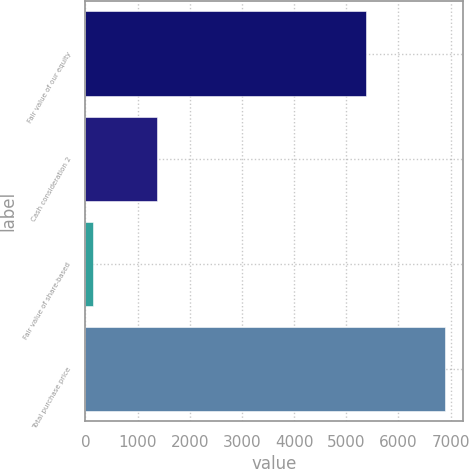<chart> <loc_0><loc_0><loc_500><loc_500><bar_chart><fcel>Fair value of our equity<fcel>Cash consideration 2<fcel>Fair value of share-based<fcel>Total purchase price<nl><fcel>5373<fcel>1368<fcel>154<fcel>6895<nl></chart> 